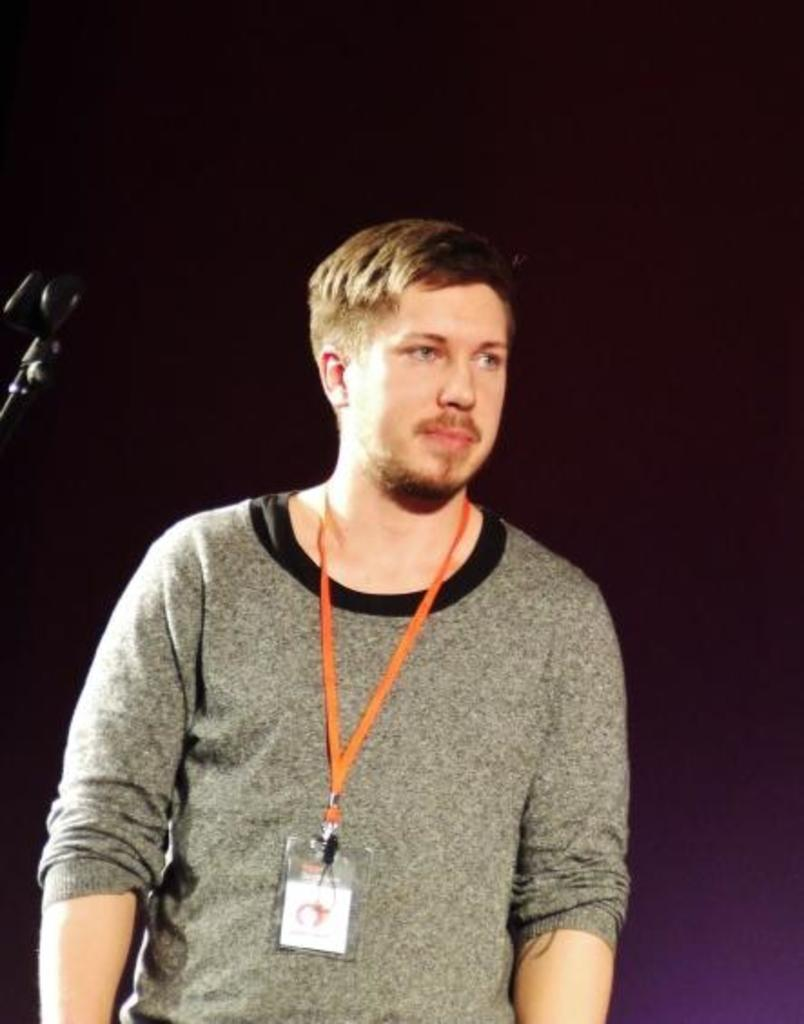What is present in the image? There is a man in the image. What is the man wearing in the image? The man is wearing an ID card. What can be observed about the background in the image? The background of the man is dark. What type of honey is the man holding in the image? There is no honey present in the image. What type of crown is the man wearing in the image? There is no crown present in the image. What type of apparel is the man wearing in the image? The only clothing item mentioned in the facts is the ID card, so there is no other specific apparel mentioned. 